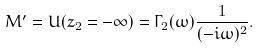<formula> <loc_0><loc_0><loc_500><loc_500>M ^ { \prime } = U ( z _ { 2 } = - \infty ) = \Gamma _ { 2 } ( \omega ) \frac { 1 } { ( - i \omega ) ^ { 2 } } .</formula> 